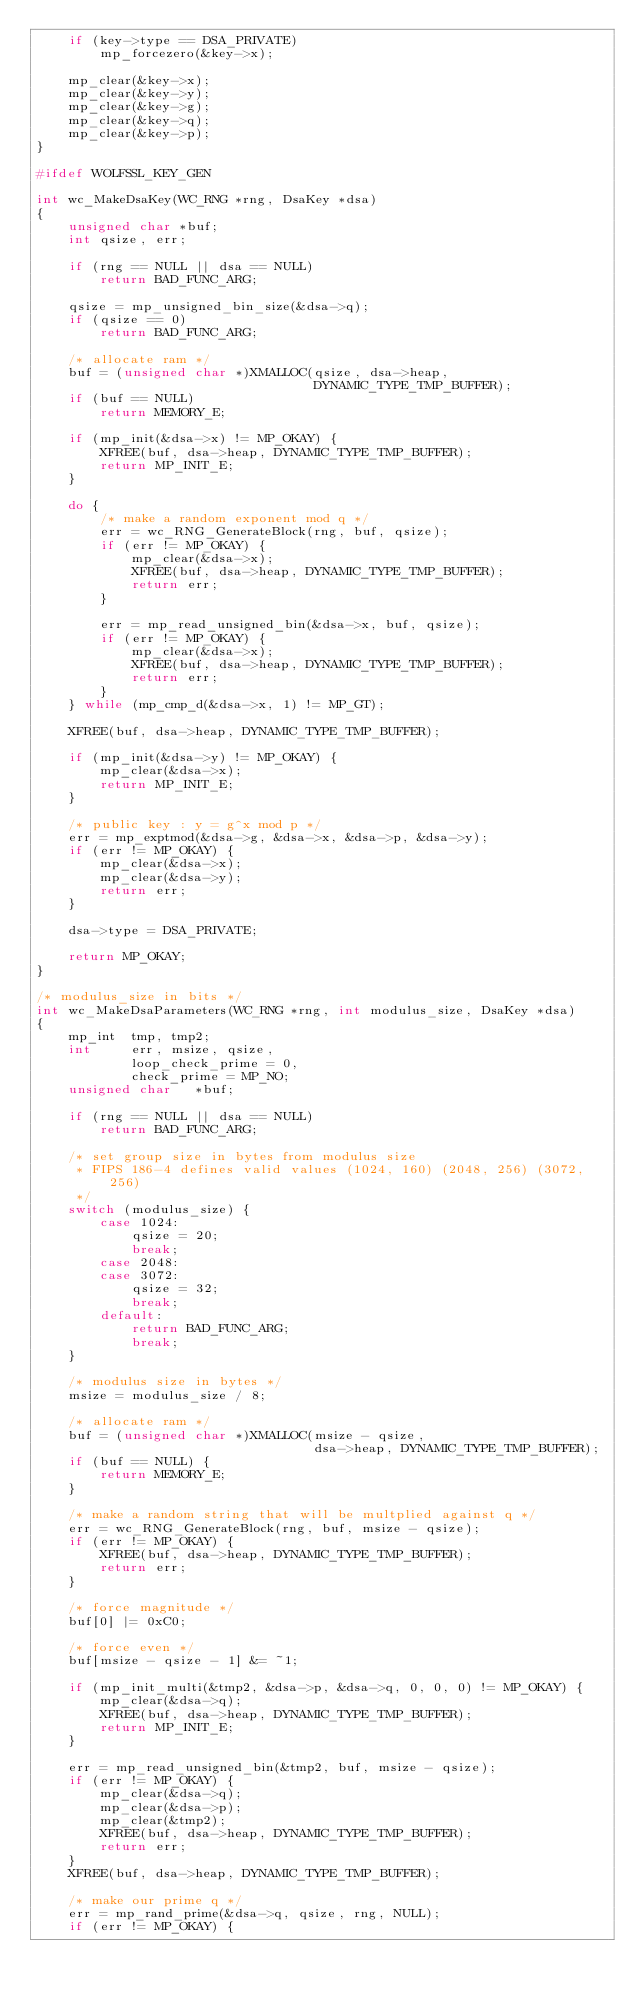<code> <loc_0><loc_0><loc_500><loc_500><_C_>    if (key->type == DSA_PRIVATE)
        mp_forcezero(&key->x);

    mp_clear(&key->x);
    mp_clear(&key->y);
    mp_clear(&key->g);
    mp_clear(&key->q);
    mp_clear(&key->p);
}

#ifdef WOLFSSL_KEY_GEN

int wc_MakeDsaKey(WC_RNG *rng, DsaKey *dsa)
{
    unsigned char *buf;
    int qsize, err;

    if (rng == NULL || dsa == NULL)
        return BAD_FUNC_ARG;

    qsize = mp_unsigned_bin_size(&dsa->q);
    if (qsize == 0)
        return BAD_FUNC_ARG;

    /* allocate ram */
    buf = (unsigned char *)XMALLOC(qsize, dsa->heap,
                                   DYNAMIC_TYPE_TMP_BUFFER);
    if (buf == NULL)
        return MEMORY_E;

    if (mp_init(&dsa->x) != MP_OKAY) {
        XFREE(buf, dsa->heap, DYNAMIC_TYPE_TMP_BUFFER);
        return MP_INIT_E;
    }

    do {
        /* make a random exponent mod q */
        err = wc_RNG_GenerateBlock(rng, buf, qsize);
        if (err != MP_OKAY) {
            mp_clear(&dsa->x);
            XFREE(buf, dsa->heap, DYNAMIC_TYPE_TMP_BUFFER);
            return err;
        }

        err = mp_read_unsigned_bin(&dsa->x, buf, qsize);
        if (err != MP_OKAY) {
            mp_clear(&dsa->x);
            XFREE(buf, dsa->heap, DYNAMIC_TYPE_TMP_BUFFER);
            return err;
        }
    } while (mp_cmp_d(&dsa->x, 1) != MP_GT);

    XFREE(buf, dsa->heap, DYNAMIC_TYPE_TMP_BUFFER);

    if (mp_init(&dsa->y) != MP_OKAY) {
        mp_clear(&dsa->x);
        return MP_INIT_E;
    }

    /* public key : y = g^x mod p */
    err = mp_exptmod(&dsa->g, &dsa->x, &dsa->p, &dsa->y);
    if (err != MP_OKAY) {
        mp_clear(&dsa->x);
        mp_clear(&dsa->y);
        return err;
    }

    dsa->type = DSA_PRIVATE;

    return MP_OKAY;
}

/* modulus_size in bits */
int wc_MakeDsaParameters(WC_RNG *rng, int modulus_size, DsaKey *dsa)
{
    mp_int  tmp, tmp2;
    int     err, msize, qsize,
            loop_check_prime = 0,
            check_prime = MP_NO;
    unsigned char   *buf;

    if (rng == NULL || dsa == NULL)
        return BAD_FUNC_ARG;

    /* set group size in bytes from modulus size
     * FIPS 186-4 defines valid values (1024, 160) (2048, 256) (3072, 256)
     */
    switch (modulus_size) {
        case 1024:
            qsize = 20;
            break;
        case 2048:
        case 3072:
            qsize = 32;
            break;
        default:
            return BAD_FUNC_ARG;
            break;
    }

    /* modulus size in bytes */
    msize = modulus_size / 8;

    /* allocate ram */
    buf = (unsigned char *)XMALLOC(msize - qsize,
                                   dsa->heap, DYNAMIC_TYPE_TMP_BUFFER);
    if (buf == NULL) {
        return MEMORY_E;
    }

    /* make a random string that will be multplied against q */
    err = wc_RNG_GenerateBlock(rng, buf, msize - qsize);
    if (err != MP_OKAY) {
        XFREE(buf, dsa->heap, DYNAMIC_TYPE_TMP_BUFFER);
        return err;
    }

    /* force magnitude */
    buf[0] |= 0xC0;

    /* force even */
    buf[msize - qsize - 1] &= ~1;

    if (mp_init_multi(&tmp2, &dsa->p, &dsa->q, 0, 0, 0) != MP_OKAY) {
        mp_clear(&dsa->q);
        XFREE(buf, dsa->heap, DYNAMIC_TYPE_TMP_BUFFER);
        return MP_INIT_E;
    }

    err = mp_read_unsigned_bin(&tmp2, buf, msize - qsize);
    if (err != MP_OKAY) {
        mp_clear(&dsa->q);
        mp_clear(&dsa->p);
        mp_clear(&tmp2);
        XFREE(buf, dsa->heap, DYNAMIC_TYPE_TMP_BUFFER);
        return err;
    }
    XFREE(buf, dsa->heap, DYNAMIC_TYPE_TMP_BUFFER);

    /* make our prime q */
    err = mp_rand_prime(&dsa->q, qsize, rng, NULL);
    if (err != MP_OKAY) {</code> 